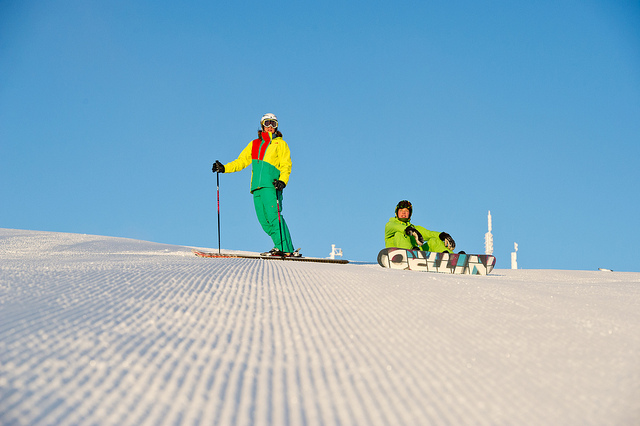Identify the text contained in this image. NITRO 